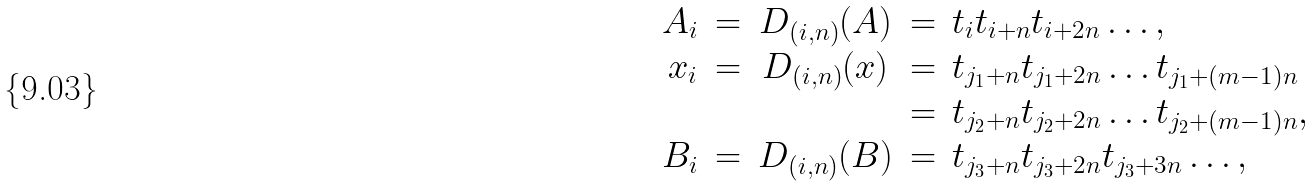<formula> <loc_0><loc_0><loc_500><loc_500>\begin{array} { r c c c l } A _ { i } & = & D _ { ( i , n ) } ( A ) & = & t _ { i } t _ { i + n } t _ { i + 2 n } \dots , \\ x _ { i } & = & D _ { ( i , n ) } ( x ) & = & t _ { j _ { 1 } + n } t _ { j _ { 1 } + 2 n } \dots t _ { j _ { 1 } + ( m - 1 ) n } \\ & & & = & t _ { j _ { 2 } + n } t _ { j _ { 2 } + 2 n } \dots t _ { j _ { 2 } + ( m - 1 ) n } , \\ B _ { i } & = & D _ { ( i , n ) } ( B ) & = & t _ { j _ { 3 } + n } t _ { j _ { 3 } + 2 n } t _ { j _ { 3 } + 3 n } \dots , \end{array}</formula> 